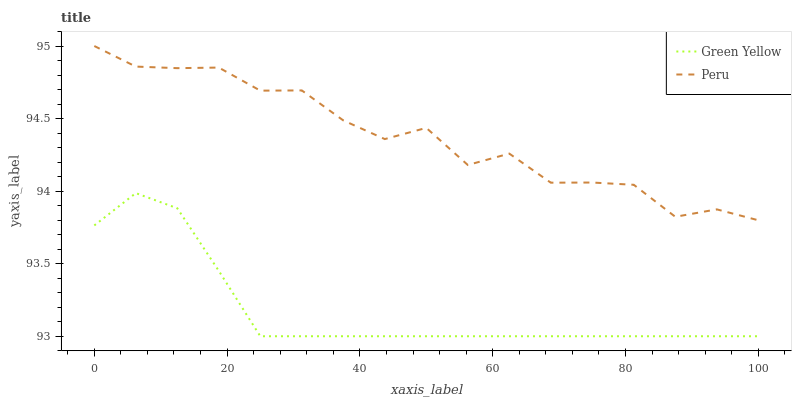Does Green Yellow have the minimum area under the curve?
Answer yes or no. Yes. Does Peru have the maximum area under the curve?
Answer yes or no. Yes. Does Peru have the minimum area under the curve?
Answer yes or no. No. Is Green Yellow the smoothest?
Answer yes or no. Yes. Is Peru the roughest?
Answer yes or no. Yes. Is Peru the smoothest?
Answer yes or no. No. Does Green Yellow have the lowest value?
Answer yes or no. Yes. Does Peru have the lowest value?
Answer yes or no. No. Does Peru have the highest value?
Answer yes or no. Yes. Is Green Yellow less than Peru?
Answer yes or no. Yes. Is Peru greater than Green Yellow?
Answer yes or no. Yes. Does Green Yellow intersect Peru?
Answer yes or no. No. 